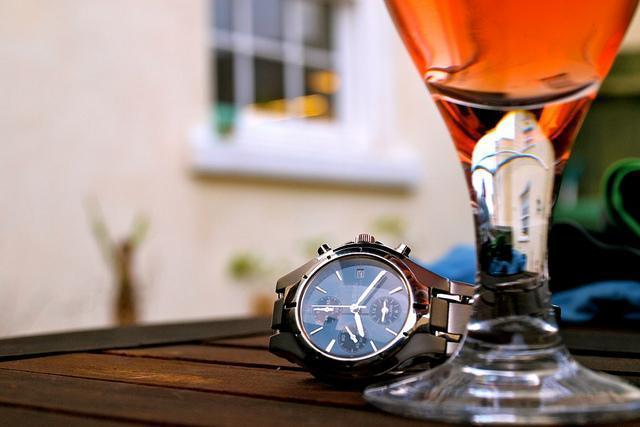How many trains are there?
Give a very brief answer. 0. 